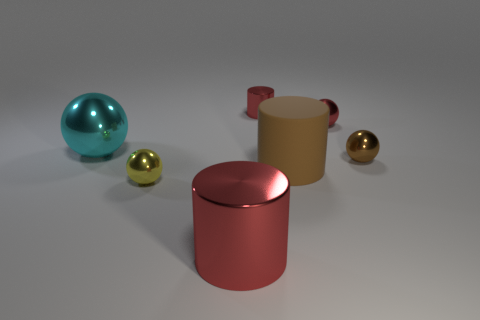Subtract all tiny shiny balls. How many balls are left? 1 Add 3 large cyan shiny spheres. How many objects exist? 10 Subtract all cyan spheres. How many spheres are left? 3 Subtract all spheres. How many objects are left? 3 Subtract 2 cylinders. How many cylinders are left? 1 Add 5 small shiny objects. How many small shiny objects are left? 9 Add 1 small brown objects. How many small brown objects exist? 2 Subtract 0 gray spheres. How many objects are left? 7 Subtract all purple cylinders. Subtract all gray spheres. How many cylinders are left? 3 Subtract all green balls. How many red cylinders are left? 2 